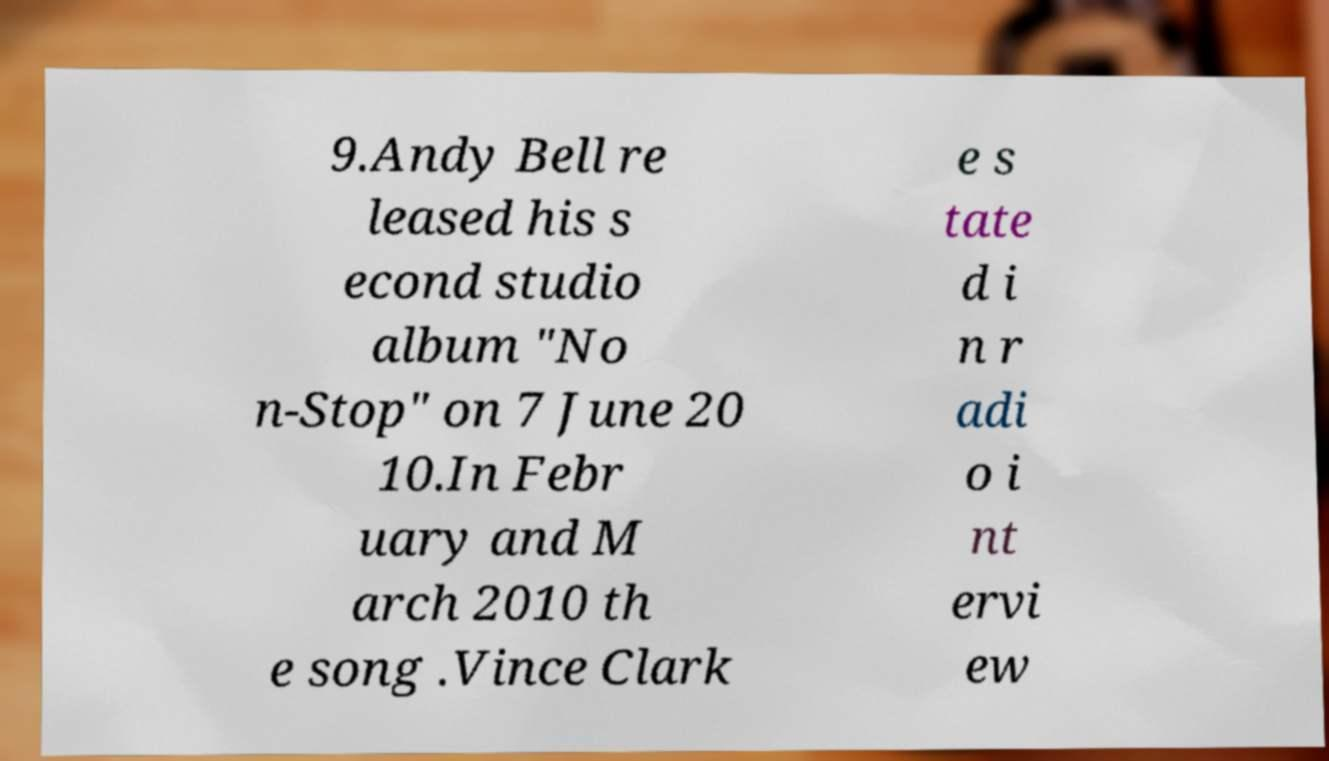There's text embedded in this image that I need extracted. Can you transcribe it verbatim? 9.Andy Bell re leased his s econd studio album "No n-Stop" on 7 June 20 10.In Febr uary and M arch 2010 th e song .Vince Clark e s tate d i n r adi o i nt ervi ew 